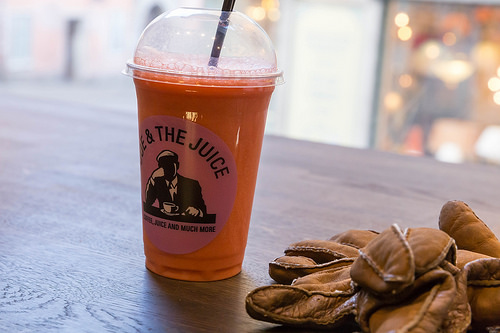<image>
Is there a cloves to the left of the juice? No. The cloves is not to the left of the juice. From this viewpoint, they have a different horizontal relationship. 